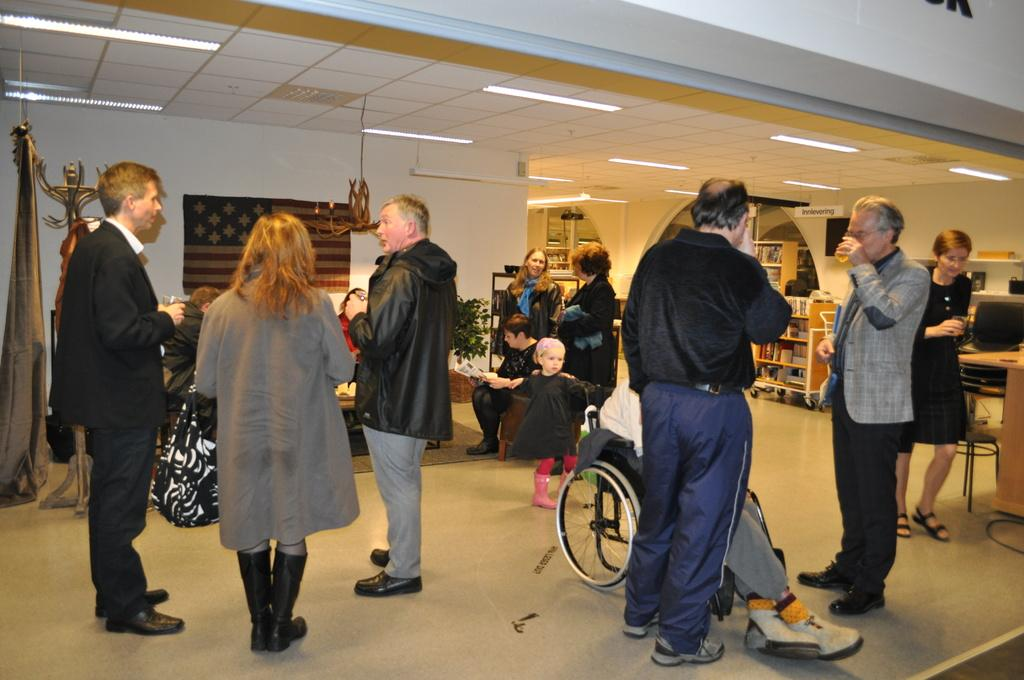What is the general activity of the people in the image? The people in the image are standing. Can you describe the condition of one of the individuals? One person is in a wheelchair. What type of furniture is present in the image? There are tables in the image. What type of storage or display feature is present in the image? There are shelves in the image. What type of patch is being exchanged between the people in the image? There is no patch exchange depicted in the image. How does the person in the wheelchair take a breath in the image? The image does not show the person in the wheelchair taking a breath, nor does it provide any information about their breathing. 